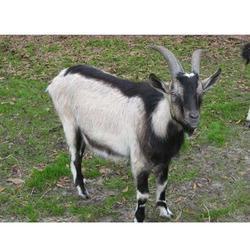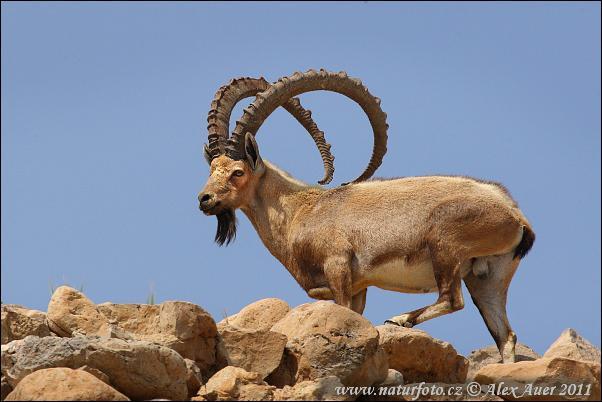The first image is the image on the left, the second image is the image on the right. Analyze the images presented: Is the assertion "One big horn sheep is facing left." valid? Answer yes or no. Yes. The first image is the image on the left, the second image is the image on the right. Given the left and right images, does the statement "There are at least three mountain goats." hold true? Answer yes or no. No. 